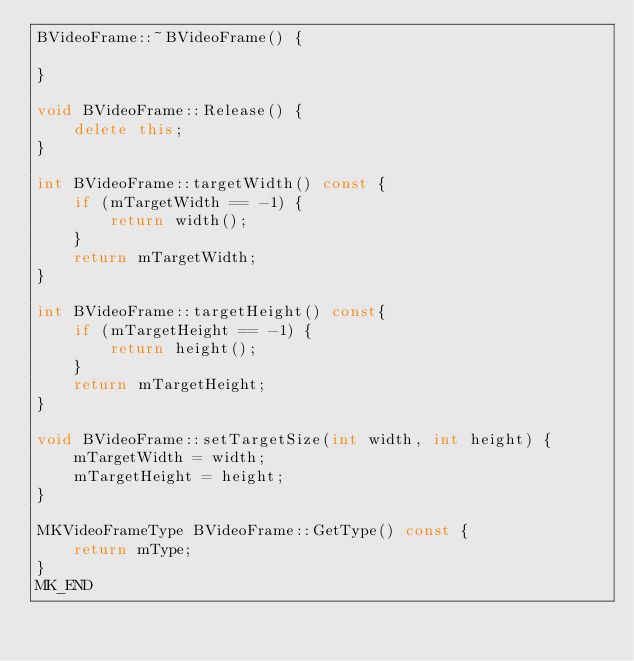Convert code to text. <code><loc_0><loc_0><loc_500><loc_500><_C++_>BVideoFrame::~BVideoFrame() {
    
}

void BVideoFrame::Release() {
    delete this;
}

int BVideoFrame::targetWidth() const {
    if (mTargetWidth == -1) {
        return width();
    }
    return mTargetWidth;
}

int BVideoFrame::targetHeight() const{
    if (mTargetHeight == -1) {
        return height();
    }
    return mTargetHeight;
}

void BVideoFrame::setTargetSize(int width, int height) {
    mTargetWidth = width;
    mTargetHeight = height;
}

MKVideoFrameType BVideoFrame::GetType() const {
    return mType;
}
MK_END

</code> 